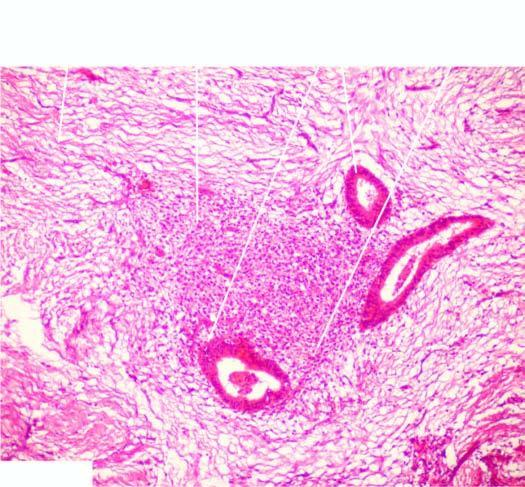does the cyst wall contain endometrial glands, stroma and evidence of preceding old haemorrhage?
Answer the question using a single word or phrase. No 